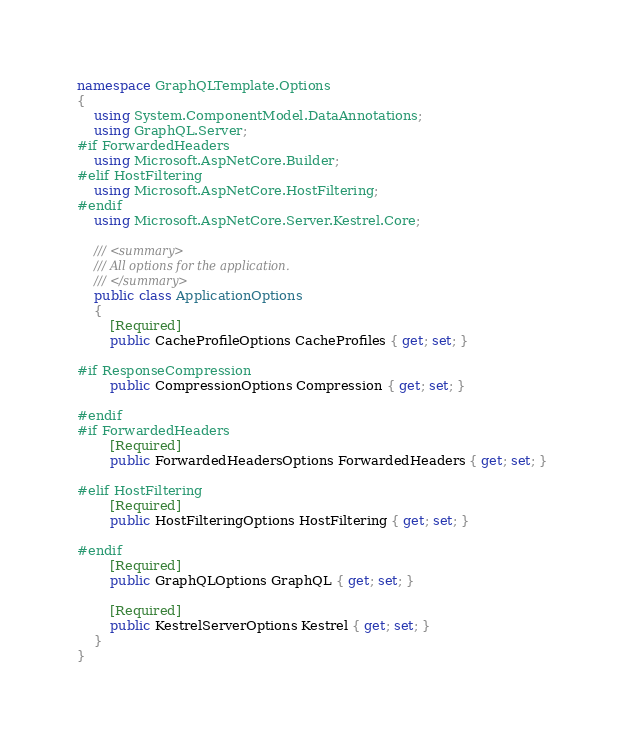Convert code to text. <code><loc_0><loc_0><loc_500><loc_500><_C#_>namespace GraphQLTemplate.Options
{
    using System.ComponentModel.DataAnnotations;
    using GraphQL.Server;
#if ForwardedHeaders
    using Microsoft.AspNetCore.Builder;
#elif HostFiltering
    using Microsoft.AspNetCore.HostFiltering;
#endif
    using Microsoft.AspNetCore.Server.Kestrel.Core;

    /// <summary>
    /// All options for the application.
    /// </summary>
    public class ApplicationOptions
    {
        [Required]
        public CacheProfileOptions CacheProfiles { get; set; }

#if ResponseCompression
        public CompressionOptions Compression { get; set; }

#endif
#if ForwardedHeaders
        [Required]
        public ForwardedHeadersOptions ForwardedHeaders { get; set; }

#elif HostFiltering
        [Required]
        public HostFilteringOptions HostFiltering { get; set; }

#endif
        [Required]
        public GraphQLOptions GraphQL { get; set; }

        [Required]
        public KestrelServerOptions Kestrel { get; set; }
    }
}
</code> 